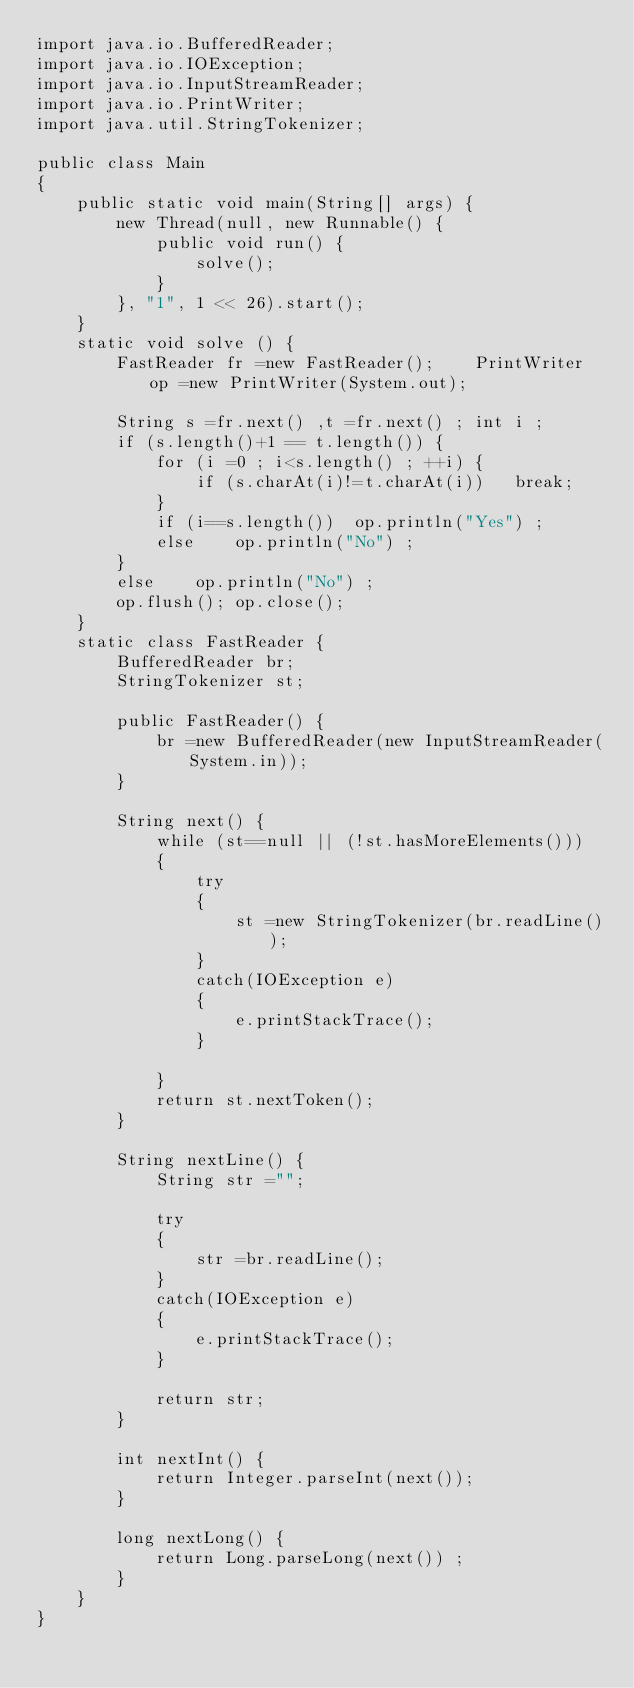<code> <loc_0><loc_0><loc_500><loc_500><_Java_>import java.io.BufferedReader;
import java.io.IOException;
import java.io.InputStreamReader;
import java.io.PrintWriter;
import java.util.StringTokenizer;

public class Main
{
	public static void main(String[] args) {
		new Thread(null, new Runnable() {
			public void run() {
                solve();
            }
        }, "1", 1 << 26).start();
	}
	static void solve () {
		FastReader fr =new FastReader();	PrintWriter op =new PrintWriter(System.out);
 
 		String s =fr.next() ,t =fr.next() ;	int i ;
 		if (s.length()+1 == t.length()) {
 			for (i =0 ; i<s.length() ; ++i) {
 				if (s.charAt(i)!=t.charAt(i))	break;
 			}
 			if (i==s.length())	op.println("Yes") ;
 			else 	op.println("No") ;
 		}
 		else 	op.println("No") ;
		op.flush();	op.close();
	}
	static class FastReader {
		BufferedReader br;
		StringTokenizer st;

		public FastReader() {
			br =new BufferedReader(new InputStreamReader(System.in));
		}

		String next() {
			while (st==null || (!st.hasMoreElements())) 
			{
				try
				{
					st =new StringTokenizer(br.readLine());
				}
				catch(IOException e)
				{
					e.printStackTrace();
				}
				
			}
			return st.nextToken();
		}

		String nextLine() {
			String str ="";

			try
			{
				str =br.readLine();
			}
			catch(IOException e)
			{
				e.printStackTrace();
			}

			return str;
		}

		int nextInt() {
			return Integer.parseInt(next());
		}

		long nextLong() {
			return Long.parseLong(next()) ;
		}
	}
}</code> 